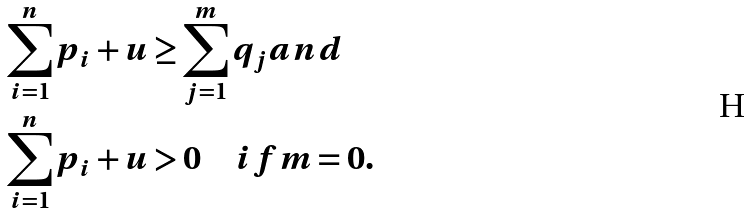Convert formula to latex. <formula><loc_0><loc_0><loc_500><loc_500>\sum _ { i = 1 } ^ { n } p _ { i } + u & \geq \sum _ { j = 1 } ^ { m } q _ { j } a n d \\ \sum _ { i = 1 } ^ { n } p _ { i } + u & > 0 \quad i f m = 0 .</formula> 